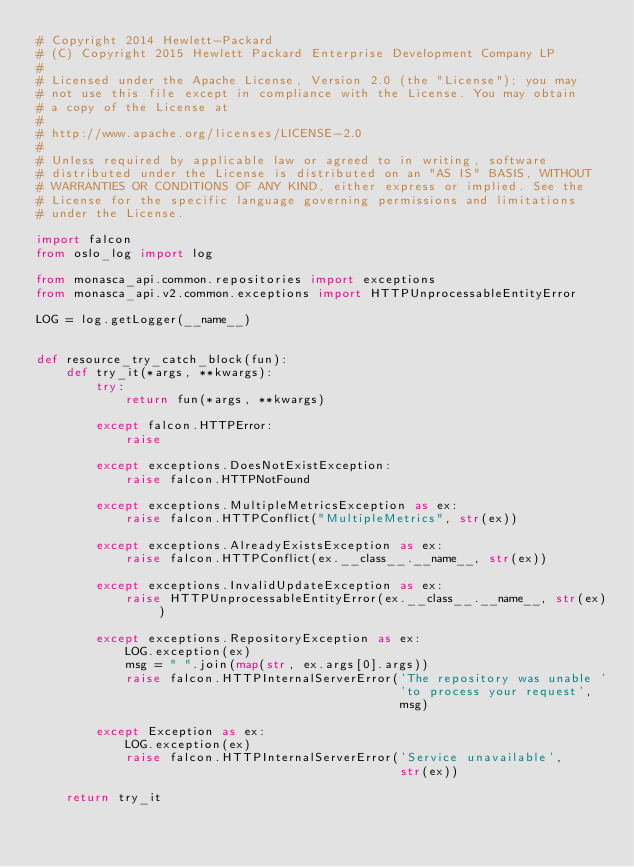<code> <loc_0><loc_0><loc_500><loc_500><_Python_># Copyright 2014 Hewlett-Packard
# (C) Copyright 2015 Hewlett Packard Enterprise Development Company LP
#
# Licensed under the Apache License, Version 2.0 (the "License"); you may
# not use this file except in compliance with the License. You may obtain
# a copy of the License at
#
# http://www.apache.org/licenses/LICENSE-2.0
#
# Unless required by applicable law or agreed to in writing, software
# distributed under the License is distributed on an "AS IS" BASIS, WITHOUT
# WARRANTIES OR CONDITIONS OF ANY KIND, either express or implied. See the
# License for the specific language governing permissions and limitations
# under the License.

import falcon
from oslo_log import log

from monasca_api.common.repositories import exceptions
from monasca_api.v2.common.exceptions import HTTPUnprocessableEntityError

LOG = log.getLogger(__name__)


def resource_try_catch_block(fun):
    def try_it(*args, **kwargs):
        try:
            return fun(*args, **kwargs)

        except falcon.HTTPError:
            raise

        except exceptions.DoesNotExistException:
            raise falcon.HTTPNotFound

        except exceptions.MultipleMetricsException as ex:
            raise falcon.HTTPConflict("MultipleMetrics", str(ex))

        except exceptions.AlreadyExistsException as ex:
            raise falcon.HTTPConflict(ex.__class__.__name__, str(ex))

        except exceptions.InvalidUpdateException as ex:
            raise HTTPUnprocessableEntityError(ex.__class__.__name__, str(ex))

        except exceptions.RepositoryException as ex:
            LOG.exception(ex)
            msg = " ".join(map(str, ex.args[0].args))
            raise falcon.HTTPInternalServerError('The repository was unable '
                                                 'to process your request',
                                                 msg)

        except Exception as ex:
            LOG.exception(ex)
            raise falcon.HTTPInternalServerError('Service unavailable',
                                                 str(ex))

    return try_it
</code> 